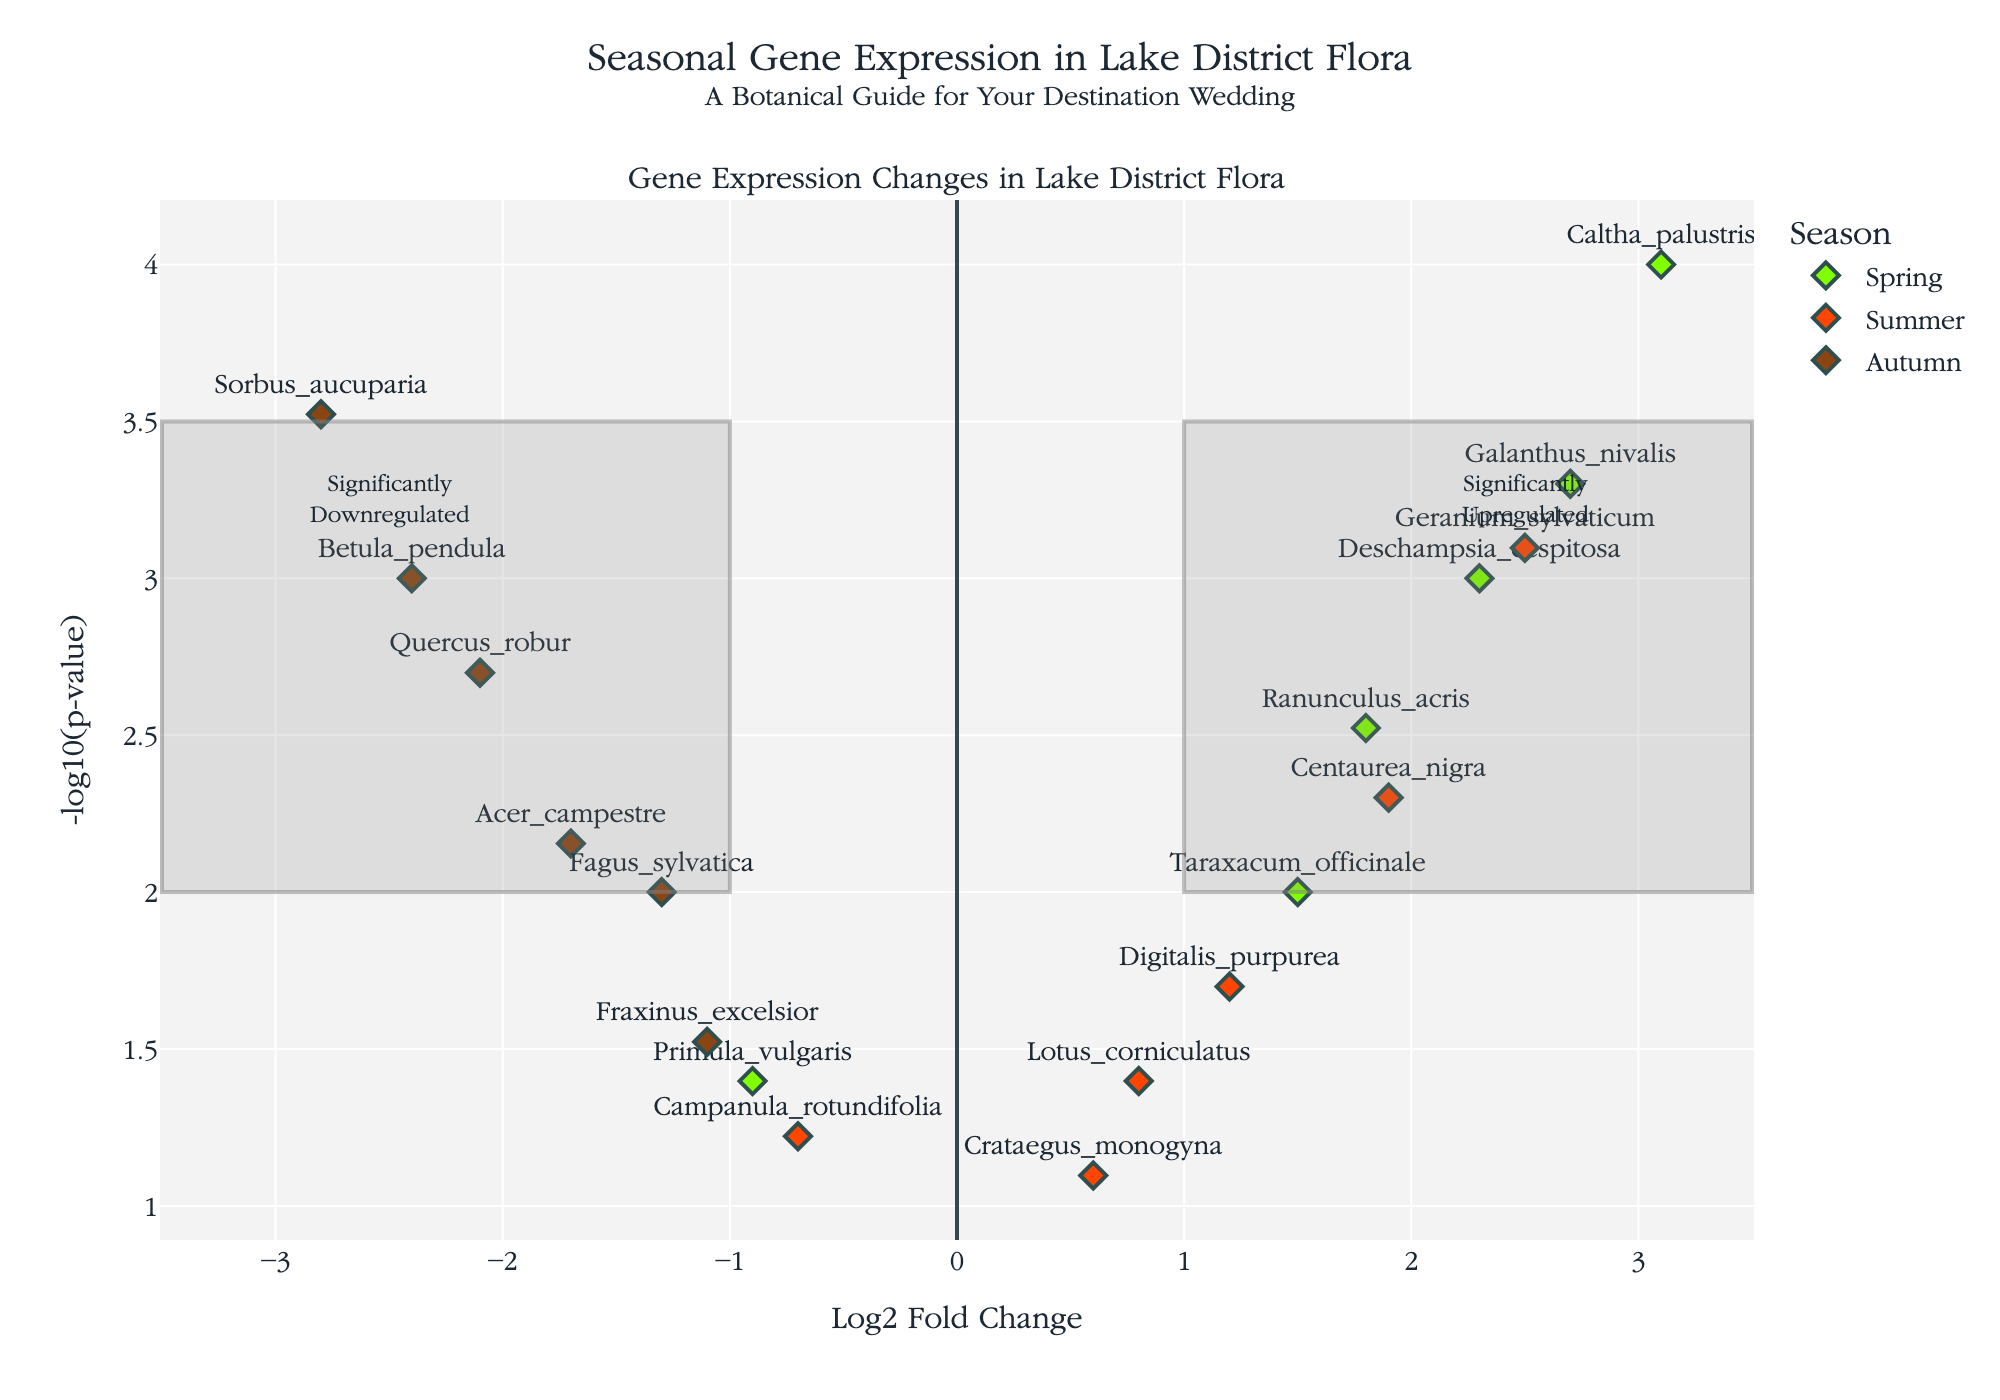What's the title of the plot? The title of the plot is written at the top and it reads: "Seasonal Gene Expression in Lake District Flora".
Answer: Seasonal Gene Expression in Lake District Flora How is the X-axis labeled? The X-axis label is presented along the horizontal axis and it reads: "Log2 Fold Change".
Answer: Log2 Fold Change Which season has the most significantly upregulated gene? By looking at the upper-right quadrant of the plot, we see a high concentration of green points representing "Spring", indicating it has most of the significantly upregulated genes.
Answer: Spring Which gene in Autumn has the most significant p-value? On the plot, genes from Autumn are marked in brown. The highest point on the vertical axis among these is the gene "Sorbus_aucuparia" with the smallest p-value (since -log10(p-value) is highest).
Answer: Sorbus_aucuparia How many genes in Summer have been significantly upregulated? Significantly upregulated genes are in the upper-right quadrant. There are orange points representing Summer: "Digitalis_purpurea", "Geranium_sylvaticum", and "Centaurea_nigra". Count these to find there are three.
Answer: 3 Which gene has the highest Log2 Fold Change in Spring? In the Spring category (green points), the gene with the highest Log2 Fold Change on the X-axis is "Caltha_palustris".
Answer: Caltha_palustris Compare the Log2 Fold Change of "Fraxinus_excelsior" and "Quercus_robur" in Autumn. Which is more downregulated? Both are Autumn genes marked in brown. "Fraxinus_excelsior" has a Log2 Fold Change of -1.1, while "Quercus_robur" has -2.1. The more negative value, -2.1, represents a greater downregulation.
Answer: Quercus_robur Are there any significantly downregulated genes in Spring? Significantly downregulated genes would appear in the upper-left quadrant. The green points representing Spring all appear to be upregulated, with no points in the upper-left quadrant.
Answer: No What are the prominently upregulated genes in Summer? In the upper-right quadrant for Summer (orange points), the prominently upregulated genes are "Digitalis_purpurea", "Geranium_sylvaticum", and "Centaurea_nigra".
Answer: Digitalis_purpurea, Geranium_sylvaticum, Centaurea_nigra Which gene in Spring has the lowest Log2 Fold Change? In Spring (green points), the gene with the lowest value on the X-axis is "Primula_vulgaris".
Answer: Primula_vulgaris 